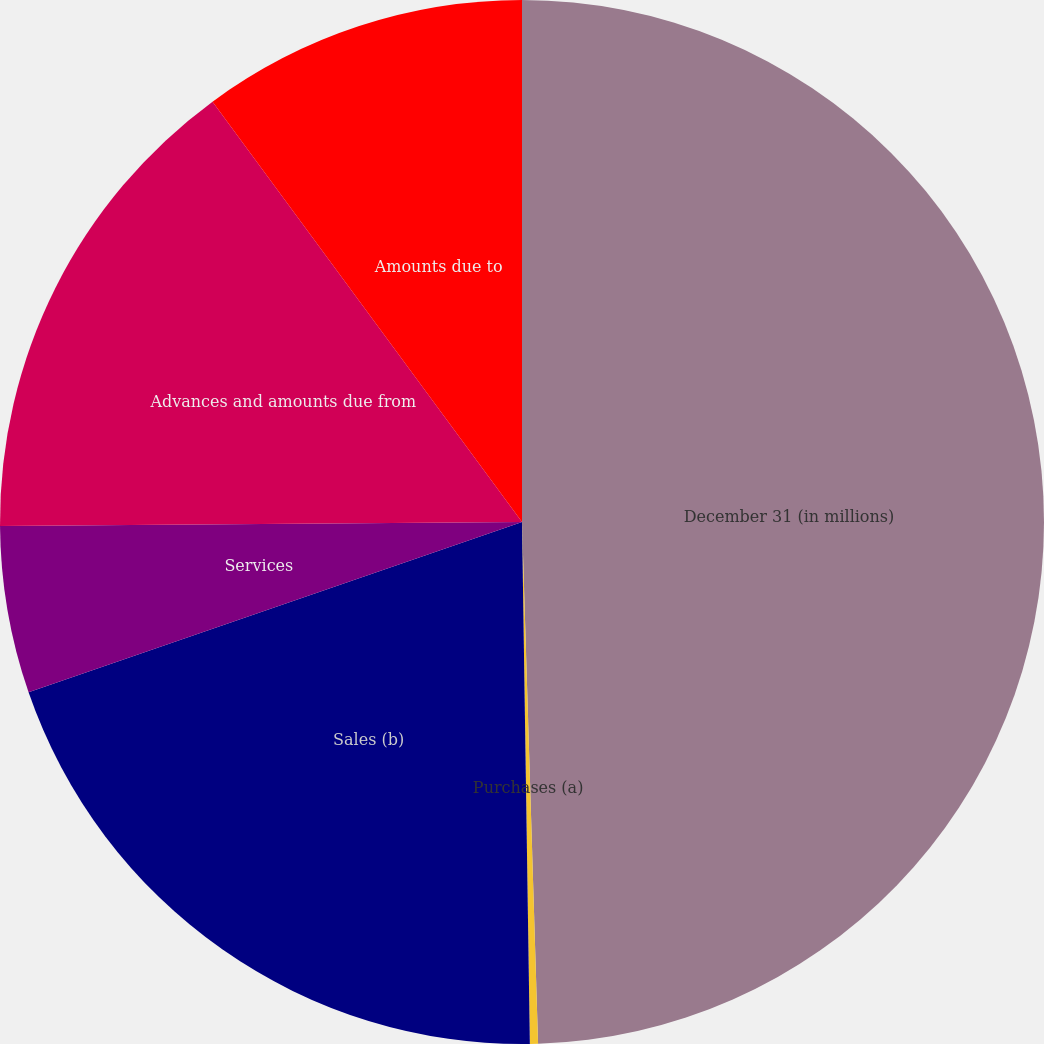Convert chart to OTSL. <chart><loc_0><loc_0><loc_500><loc_500><pie_chart><fcel>December 31 (in millions)<fcel>Purchases (a)<fcel>Sales (b)<fcel>Services<fcel>Advances and amounts due from<fcel>Amounts due to<nl><fcel>49.51%<fcel>0.25%<fcel>19.95%<fcel>5.17%<fcel>15.02%<fcel>10.1%<nl></chart> 